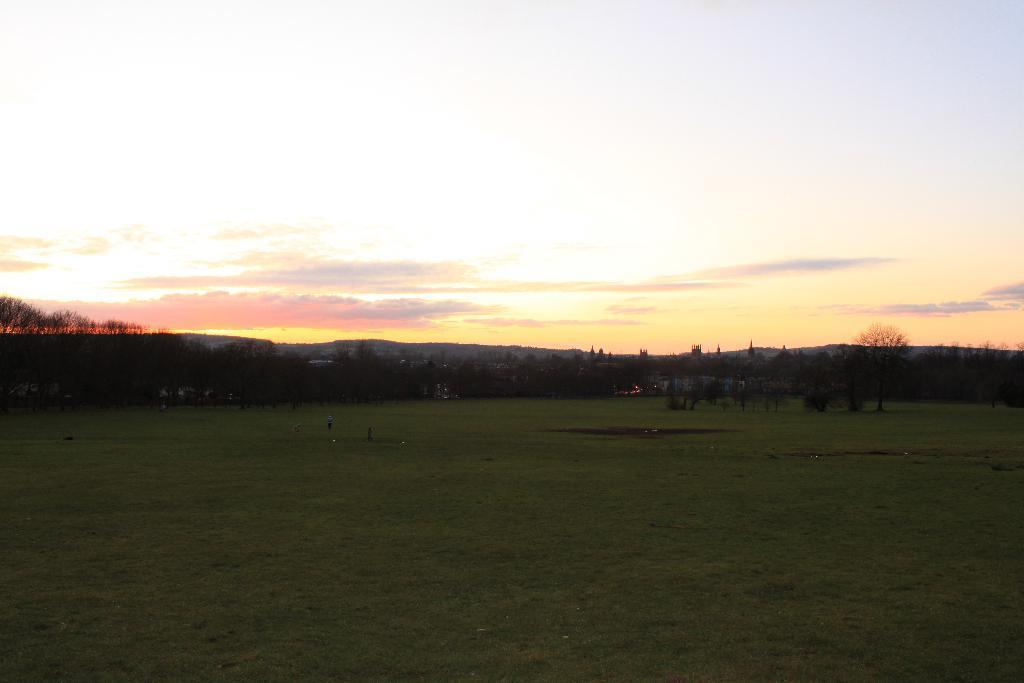Could you give a brief overview of what you see in this image? In this image we can see ground, trees, hills and sky with clouds. 